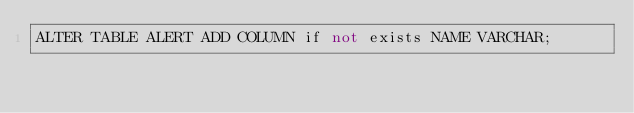Convert code to text. <code><loc_0><loc_0><loc_500><loc_500><_SQL_>ALTER TABLE ALERT ADD COLUMN if not exists NAME VARCHAR;
</code> 